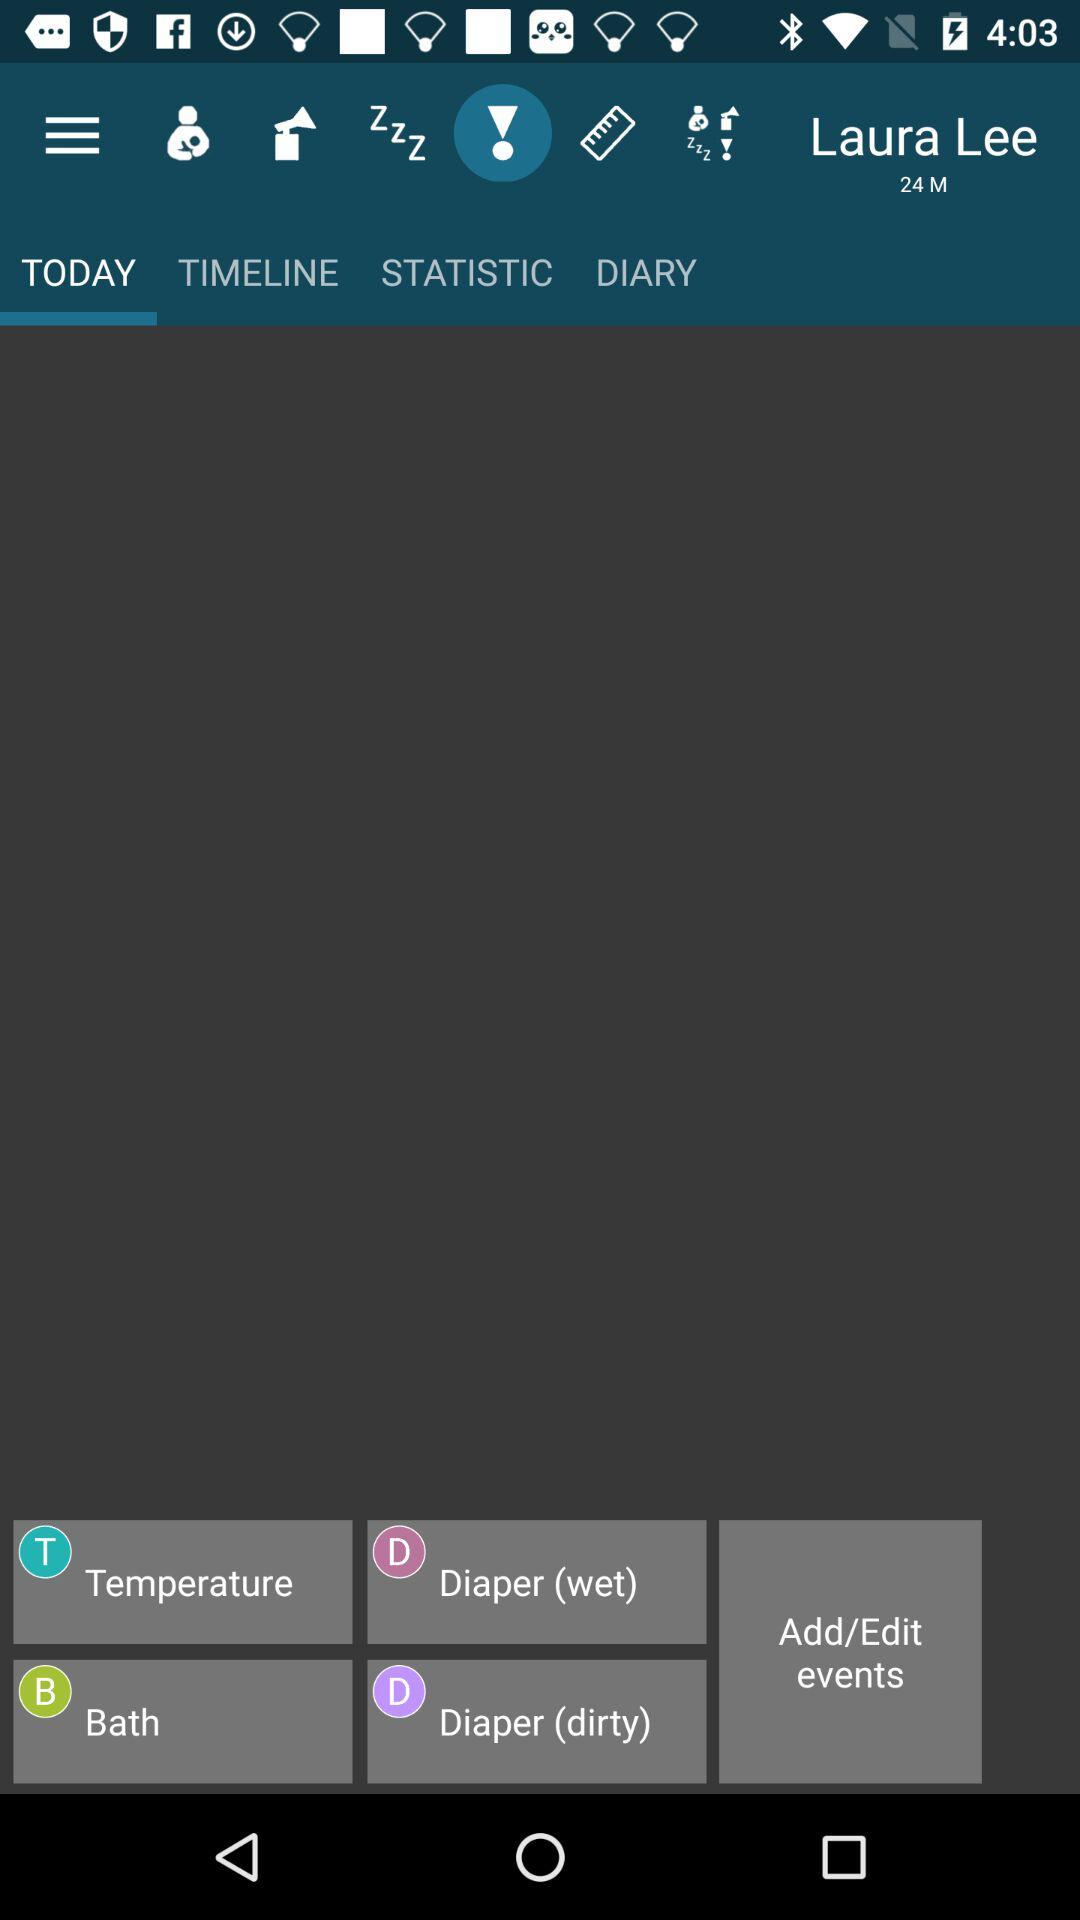What is the age of Laura Lee? The age of Laura Lee is 24. 